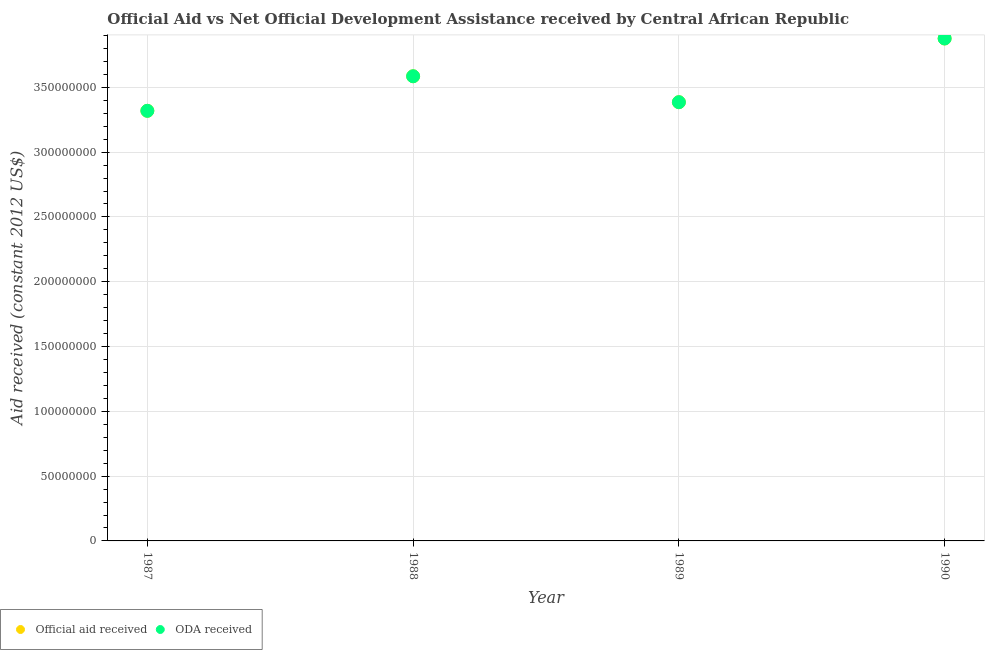How many different coloured dotlines are there?
Give a very brief answer. 2. Is the number of dotlines equal to the number of legend labels?
Offer a very short reply. Yes. What is the oda received in 1988?
Ensure brevity in your answer.  3.59e+08. Across all years, what is the maximum official aid received?
Make the answer very short. 3.88e+08. Across all years, what is the minimum oda received?
Provide a short and direct response. 3.32e+08. In which year was the official aid received maximum?
Provide a succinct answer. 1990. What is the total official aid received in the graph?
Your answer should be very brief. 1.42e+09. What is the difference between the oda received in 1989 and that in 1990?
Your answer should be very brief. -4.92e+07. What is the difference between the oda received in 1987 and the official aid received in 1990?
Give a very brief answer. -5.58e+07. What is the average oda received per year?
Ensure brevity in your answer.  3.54e+08. What is the ratio of the official aid received in 1987 to that in 1988?
Keep it short and to the point. 0.93. Is the oda received in 1988 less than that in 1989?
Offer a terse response. No. Is the difference between the official aid received in 1988 and 1990 greater than the difference between the oda received in 1988 and 1990?
Offer a terse response. No. What is the difference between the highest and the second highest oda received?
Offer a terse response. 2.91e+07. What is the difference between the highest and the lowest oda received?
Offer a very short reply. 5.58e+07. Is the official aid received strictly greater than the oda received over the years?
Ensure brevity in your answer.  No. What is the difference between two consecutive major ticks on the Y-axis?
Offer a terse response. 5.00e+07. Are the values on the major ticks of Y-axis written in scientific E-notation?
Your answer should be compact. No. Does the graph contain any zero values?
Provide a short and direct response. No. Does the graph contain grids?
Give a very brief answer. Yes. Where does the legend appear in the graph?
Make the answer very short. Bottom left. How many legend labels are there?
Offer a very short reply. 2. What is the title of the graph?
Make the answer very short. Official Aid vs Net Official Development Assistance received by Central African Republic . Does "Net National savings" appear as one of the legend labels in the graph?
Give a very brief answer. No. What is the label or title of the Y-axis?
Give a very brief answer. Aid received (constant 2012 US$). What is the Aid received (constant 2012 US$) in Official aid received in 1987?
Provide a succinct answer. 3.32e+08. What is the Aid received (constant 2012 US$) of ODA received in 1987?
Give a very brief answer. 3.32e+08. What is the Aid received (constant 2012 US$) in Official aid received in 1988?
Give a very brief answer. 3.59e+08. What is the Aid received (constant 2012 US$) in ODA received in 1988?
Ensure brevity in your answer.  3.59e+08. What is the Aid received (constant 2012 US$) of Official aid received in 1989?
Provide a short and direct response. 3.39e+08. What is the Aid received (constant 2012 US$) of ODA received in 1989?
Keep it short and to the point. 3.39e+08. What is the Aid received (constant 2012 US$) in Official aid received in 1990?
Your answer should be very brief. 3.88e+08. What is the Aid received (constant 2012 US$) in ODA received in 1990?
Offer a very short reply. 3.88e+08. Across all years, what is the maximum Aid received (constant 2012 US$) in Official aid received?
Ensure brevity in your answer.  3.88e+08. Across all years, what is the maximum Aid received (constant 2012 US$) in ODA received?
Make the answer very short. 3.88e+08. Across all years, what is the minimum Aid received (constant 2012 US$) of Official aid received?
Ensure brevity in your answer.  3.32e+08. Across all years, what is the minimum Aid received (constant 2012 US$) of ODA received?
Your answer should be compact. 3.32e+08. What is the total Aid received (constant 2012 US$) of Official aid received in the graph?
Provide a short and direct response. 1.42e+09. What is the total Aid received (constant 2012 US$) of ODA received in the graph?
Make the answer very short. 1.42e+09. What is the difference between the Aid received (constant 2012 US$) of Official aid received in 1987 and that in 1988?
Your answer should be very brief. -2.67e+07. What is the difference between the Aid received (constant 2012 US$) in ODA received in 1987 and that in 1988?
Make the answer very short. -2.67e+07. What is the difference between the Aid received (constant 2012 US$) in Official aid received in 1987 and that in 1989?
Ensure brevity in your answer.  -6.66e+06. What is the difference between the Aid received (constant 2012 US$) of ODA received in 1987 and that in 1989?
Ensure brevity in your answer.  -6.66e+06. What is the difference between the Aid received (constant 2012 US$) of Official aid received in 1987 and that in 1990?
Your response must be concise. -5.58e+07. What is the difference between the Aid received (constant 2012 US$) in ODA received in 1987 and that in 1990?
Your answer should be very brief. -5.58e+07. What is the difference between the Aid received (constant 2012 US$) of Official aid received in 1988 and that in 1989?
Your answer should be compact. 2.00e+07. What is the difference between the Aid received (constant 2012 US$) of ODA received in 1988 and that in 1989?
Keep it short and to the point. 2.00e+07. What is the difference between the Aid received (constant 2012 US$) of Official aid received in 1988 and that in 1990?
Your answer should be compact. -2.91e+07. What is the difference between the Aid received (constant 2012 US$) in ODA received in 1988 and that in 1990?
Your answer should be compact. -2.91e+07. What is the difference between the Aid received (constant 2012 US$) in Official aid received in 1989 and that in 1990?
Offer a very short reply. -4.92e+07. What is the difference between the Aid received (constant 2012 US$) in ODA received in 1989 and that in 1990?
Provide a short and direct response. -4.92e+07. What is the difference between the Aid received (constant 2012 US$) of Official aid received in 1987 and the Aid received (constant 2012 US$) of ODA received in 1988?
Provide a short and direct response. -2.67e+07. What is the difference between the Aid received (constant 2012 US$) of Official aid received in 1987 and the Aid received (constant 2012 US$) of ODA received in 1989?
Your answer should be compact. -6.66e+06. What is the difference between the Aid received (constant 2012 US$) in Official aid received in 1987 and the Aid received (constant 2012 US$) in ODA received in 1990?
Provide a short and direct response. -5.58e+07. What is the difference between the Aid received (constant 2012 US$) of Official aid received in 1988 and the Aid received (constant 2012 US$) of ODA received in 1989?
Make the answer very short. 2.00e+07. What is the difference between the Aid received (constant 2012 US$) in Official aid received in 1988 and the Aid received (constant 2012 US$) in ODA received in 1990?
Your response must be concise. -2.91e+07. What is the difference between the Aid received (constant 2012 US$) in Official aid received in 1989 and the Aid received (constant 2012 US$) in ODA received in 1990?
Make the answer very short. -4.92e+07. What is the average Aid received (constant 2012 US$) of Official aid received per year?
Your response must be concise. 3.54e+08. What is the average Aid received (constant 2012 US$) in ODA received per year?
Your answer should be very brief. 3.54e+08. In the year 1988, what is the difference between the Aid received (constant 2012 US$) of Official aid received and Aid received (constant 2012 US$) of ODA received?
Make the answer very short. 0. In the year 1990, what is the difference between the Aid received (constant 2012 US$) in Official aid received and Aid received (constant 2012 US$) in ODA received?
Give a very brief answer. 0. What is the ratio of the Aid received (constant 2012 US$) of Official aid received in 1987 to that in 1988?
Offer a terse response. 0.93. What is the ratio of the Aid received (constant 2012 US$) in ODA received in 1987 to that in 1988?
Your answer should be compact. 0.93. What is the ratio of the Aid received (constant 2012 US$) in Official aid received in 1987 to that in 1989?
Make the answer very short. 0.98. What is the ratio of the Aid received (constant 2012 US$) of ODA received in 1987 to that in 1989?
Your answer should be compact. 0.98. What is the ratio of the Aid received (constant 2012 US$) in Official aid received in 1987 to that in 1990?
Give a very brief answer. 0.86. What is the ratio of the Aid received (constant 2012 US$) of ODA received in 1987 to that in 1990?
Keep it short and to the point. 0.86. What is the ratio of the Aid received (constant 2012 US$) of Official aid received in 1988 to that in 1989?
Your answer should be compact. 1.06. What is the ratio of the Aid received (constant 2012 US$) in ODA received in 1988 to that in 1989?
Your answer should be very brief. 1.06. What is the ratio of the Aid received (constant 2012 US$) of Official aid received in 1988 to that in 1990?
Offer a very short reply. 0.92. What is the ratio of the Aid received (constant 2012 US$) of ODA received in 1988 to that in 1990?
Ensure brevity in your answer.  0.92. What is the ratio of the Aid received (constant 2012 US$) in Official aid received in 1989 to that in 1990?
Your answer should be compact. 0.87. What is the ratio of the Aid received (constant 2012 US$) in ODA received in 1989 to that in 1990?
Ensure brevity in your answer.  0.87. What is the difference between the highest and the second highest Aid received (constant 2012 US$) of Official aid received?
Offer a terse response. 2.91e+07. What is the difference between the highest and the second highest Aid received (constant 2012 US$) of ODA received?
Make the answer very short. 2.91e+07. What is the difference between the highest and the lowest Aid received (constant 2012 US$) of Official aid received?
Ensure brevity in your answer.  5.58e+07. What is the difference between the highest and the lowest Aid received (constant 2012 US$) in ODA received?
Your answer should be compact. 5.58e+07. 